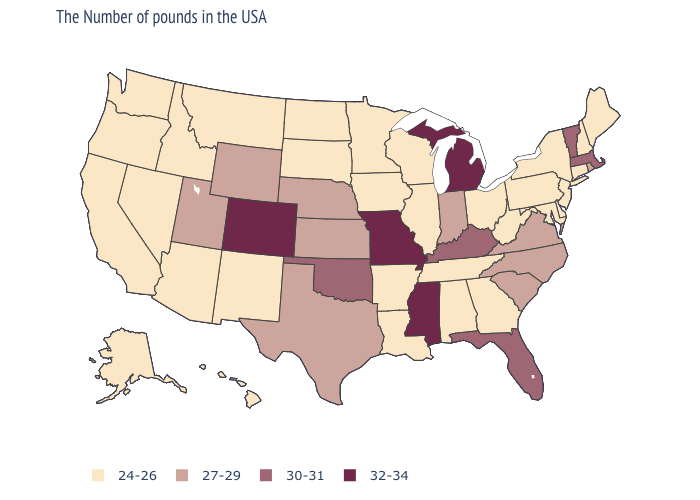Which states have the highest value in the USA?
Keep it brief. Michigan, Mississippi, Missouri, Colorado. Does the map have missing data?
Concise answer only. No. What is the value of New Mexico?
Quick response, please. 24-26. How many symbols are there in the legend?
Answer briefly. 4. What is the highest value in states that border Mississippi?
Quick response, please. 24-26. What is the value of Maryland?
Give a very brief answer. 24-26. Name the states that have a value in the range 32-34?
Write a very short answer. Michigan, Mississippi, Missouri, Colorado. Among the states that border Utah , does Arizona have the highest value?
Give a very brief answer. No. Among the states that border Arkansas , which have the lowest value?
Quick response, please. Tennessee, Louisiana. What is the lowest value in the West?
Quick response, please. 24-26. Does Missouri have the lowest value in the USA?
Write a very short answer. No. Which states have the highest value in the USA?
Keep it brief. Michigan, Mississippi, Missouri, Colorado. Which states hav the highest value in the West?
Quick response, please. Colorado. What is the value of Wisconsin?
Give a very brief answer. 24-26. What is the lowest value in the USA?
Keep it brief. 24-26. 